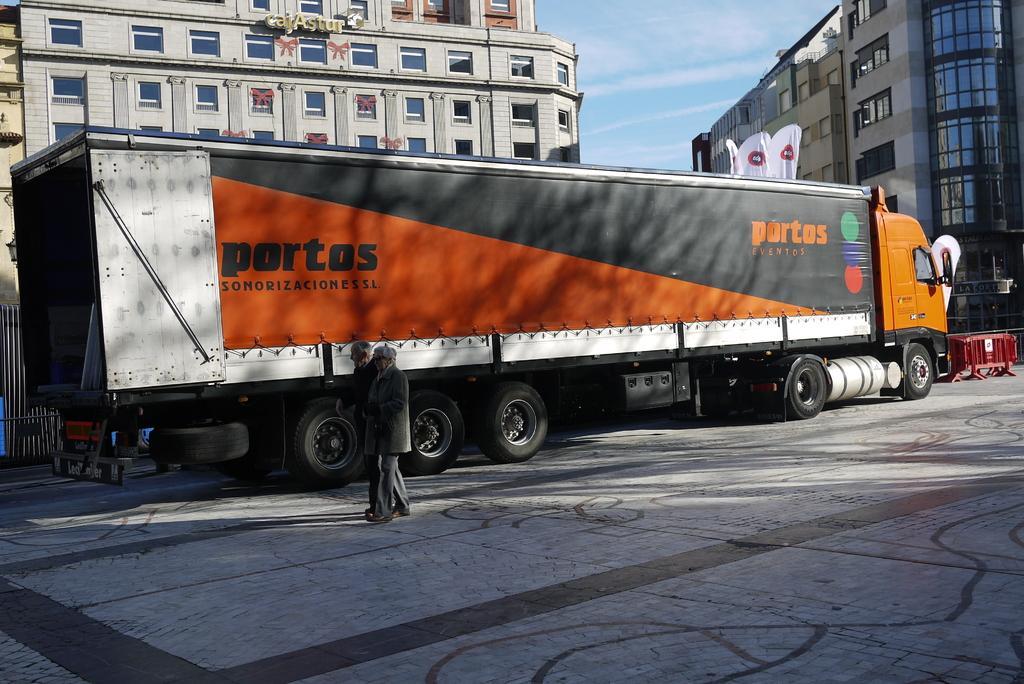Please provide a concise description of this image. In the foreground of the picture it is pavement, on the pavement there are two men walking. In the center of the picture there is a truck and there are barricades. In the background there are buildings, sky and the white color object. 